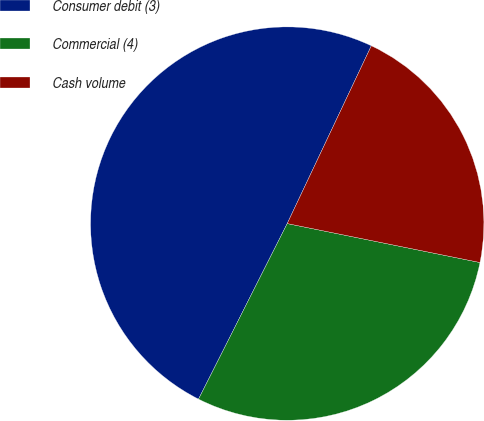Convert chart. <chart><loc_0><loc_0><loc_500><loc_500><pie_chart><fcel>Consumer debit (3)<fcel>Commercial (4)<fcel>Cash volume<nl><fcel>49.59%<fcel>29.27%<fcel>21.14%<nl></chart> 